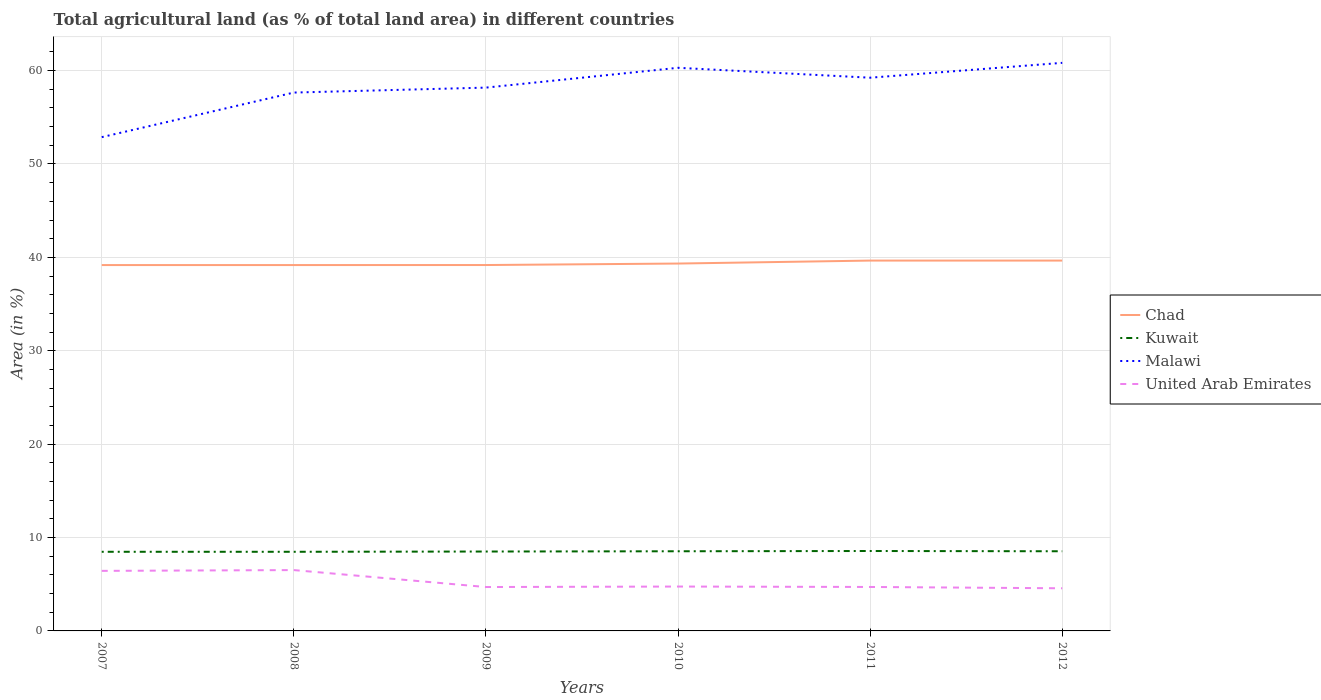Across all years, what is the maximum percentage of agricultural land in Kuwait?
Your answer should be very brief. 8.47. What is the total percentage of agricultural land in Kuwait in the graph?
Provide a short and direct response. -0.03. What is the difference between the highest and the second highest percentage of agricultural land in Kuwait?
Offer a terse response. 0.08. What is the difference between the highest and the lowest percentage of agricultural land in Kuwait?
Your answer should be compact. 3. How many lines are there?
Provide a succinct answer. 4. Does the graph contain grids?
Make the answer very short. Yes. How are the legend labels stacked?
Give a very brief answer. Vertical. What is the title of the graph?
Your answer should be compact. Total agricultural land (as % of total land area) in different countries. Does "Greece" appear as one of the legend labels in the graph?
Provide a short and direct response. No. What is the label or title of the Y-axis?
Provide a short and direct response. Area (in %). What is the Area (in %) in Chad in 2007?
Make the answer very short. 39.18. What is the Area (in %) in Kuwait in 2007?
Your answer should be very brief. 8.47. What is the Area (in %) in Malawi in 2007?
Your answer should be very brief. 52.87. What is the Area (in %) in United Arab Emirates in 2007?
Ensure brevity in your answer.  6.43. What is the Area (in %) in Chad in 2008?
Your response must be concise. 39.18. What is the Area (in %) in Kuwait in 2008?
Make the answer very short. 8.47. What is the Area (in %) in Malawi in 2008?
Ensure brevity in your answer.  57.65. What is the Area (in %) of United Arab Emirates in 2008?
Give a very brief answer. 6.51. What is the Area (in %) of Chad in 2009?
Your answer should be compact. 39.18. What is the Area (in %) of Kuwait in 2009?
Provide a short and direct response. 8.5. What is the Area (in %) in Malawi in 2009?
Keep it short and to the point. 58.18. What is the Area (in %) of United Arab Emirates in 2009?
Offer a terse response. 4.7. What is the Area (in %) in Chad in 2010?
Your answer should be very brief. 39.34. What is the Area (in %) of Kuwait in 2010?
Offer a terse response. 8.53. What is the Area (in %) in Malawi in 2010?
Offer a very short reply. 60.3. What is the Area (in %) of United Arab Emirates in 2010?
Your response must be concise. 4.75. What is the Area (in %) of Chad in 2011?
Offer a very short reply. 39.66. What is the Area (in %) of Kuwait in 2011?
Ensure brevity in your answer.  8.56. What is the Area (in %) in Malawi in 2011?
Provide a short and direct response. 59.24. What is the Area (in %) of United Arab Emirates in 2011?
Keep it short and to the point. 4.71. What is the Area (in %) of Chad in 2012?
Give a very brief answer. 39.66. What is the Area (in %) in Kuwait in 2012?
Make the answer very short. 8.53. What is the Area (in %) of Malawi in 2012?
Keep it short and to the point. 60.83. What is the Area (in %) in United Arab Emirates in 2012?
Provide a succinct answer. 4.57. Across all years, what is the maximum Area (in %) of Chad?
Make the answer very short. 39.66. Across all years, what is the maximum Area (in %) of Kuwait?
Offer a very short reply. 8.56. Across all years, what is the maximum Area (in %) of Malawi?
Provide a short and direct response. 60.83. Across all years, what is the maximum Area (in %) of United Arab Emirates?
Ensure brevity in your answer.  6.51. Across all years, what is the minimum Area (in %) in Chad?
Offer a very short reply. 39.18. Across all years, what is the minimum Area (in %) of Kuwait?
Your answer should be compact. 8.47. Across all years, what is the minimum Area (in %) of Malawi?
Your response must be concise. 52.87. Across all years, what is the minimum Area (in %) in United Arab Emirates?
Provide a short and direct response. 4.57. What is the total Area (in %) of Chad in the graph?
Ensure brevity in your answer.  236.18. What is the total Area (in %) of Kuwait in the graph?
Your answer should be very brief. 51.07. What is the total Area (in %) in Malawi in the graph?
Provide a succinct answer. 349.07. What is the total Area (in %) of United Arab Emirates in the graph?
Provide a short and direct response. 31.67. What is the difference between the Area (in %) of Kuwait in 2007 and that in 2008?
Give a very brief answer. 0. What is the difference between the Area (in %) of Malawi in 2007 and that in 2008?
Keep it short and to the point. -4.77. What is the difference between the Area (in %) in United Arab Emirates in 2007 and that in 2008?
Provide a short and direct response. -0.08. What is the difference between the Area (in %) of Chad in 2007 and that in 2009?
Offer a very short reply. -0. What is the difference between the Area (in %) in Kuwait in 2007 and that in 2009?
Your answer should be very brief. -0.03. What is the difference between the Area (in %) of Malawi in 2007 and that in 2009?
Provide a succinct answer. -5.3. What is the difference between the Area (in %) of United Arab Emirates in 2007 and that in 2009?
Offer a very short reply. 1.73. What is the difference between the Area (in %) of Chad in 2007 and that in 2010?
Offer a terse response. -0.16. What is the difference between the Area (in %) in Kuwait in 2007 and that in 2010?
Your response must be concise. -0.06. What is the difference between the Area (in %) of Malawi in 2007 and that in 2010?
Give a very brief answer. -7.42. What is the difference between the Area (in %) of United Arab Emirates in 2007 and that in 2010?
Make the answer very short. 1.68. What is the difference between the Area (in %) of Chad in 2007 and that in 2011?
Your answer should be very brief. -0.48. What is the difference between the Area (in %) of Kuwait in 2007 and that in 2011?
Provide a short and direct response. -0.08. What is the difference between the Area (in %) of Malawi in 2007 and that in 2011?
Give a very brief answer. -6.36. What is the difference between the Area (in %) of United Arab Emirates in 2007 and that in 2011?
Keep it short and to the point. 1.72. What is the difference between the Area (in %) of Chad in 2007 and that in 2012?
Offer a terse response. -0.48. What is the difference between the Area (in %) of Kuwait in 2007 and that in 2012?
Give a very brief answer. -0.06. What is the difference between the Area (in %) of Malawi in 2007 and that in 2012?
Keep it short and to the point. -7.96. What is the difference between the Area (in %) in United Arab Emirates in 2007 and that in 2012?
Offer a very short reply. 1.86. What is the difference between the Area (in %) in Chad in 2008 and that in 2009?
Offer a terse response. -0. What is the difference between the Area (in %) of Kuwait in 2008 and that in 2009?
Make the answer very short. -0.03. What is the difference between the Area (in %) in Malawi in 2008 and that in 2009?
Offer a terse response. -0.53. What is the difference between the Area (in %) of United Arab Emirates in 2008 and that in 2009?
Offer a terse response. 1.81. What is the difference between the Area (in %) of Chad in 2008 and that in 2010?
Your answer should be very brief. -0.16. What is the difference between the Area (in %) in Kuwait in 2008 and that in 2010?
Offer a terse response. -0.06. What is the difference between the Area (in %) in Malawi in 2008 and that in 2010?
Keep it short and to the point. -2.65. What is the difference between the Area (in %) in United Arab Emirates in 2008 and that in 2010?
Offer a very short reply. 1.76. What is the difference between the Area (in %) in Chad in 2008 and that in 2011?
Provide a short and direct response. -0.48. What is the difference between the Area (in %) of Kuwait in 2008 and that in 2011?
Offer a terse response. -0.08. What is the difference between the Area (in %) in Malawi in 2008 and that in 2011?
Your answer should be compact. -1.59. What is the difference between the Area (in %) of United Arab Emirates in 2008 and that in 2011?
Ensure brevity in your answer.  1.81. What is the difference between the Area (in %) of Chad in 2008 and that in 2012?
Give a very brief answer. -0.48. What is the difference between the Area (in %) in Kuwait in 2008 and that in 2012?
Ensure brevity in your answer.  -0.06. What is the difference between the Area (in %) of Malawi in 2008 and that in 2012?
Keep it short and to the point. -3.18. What is the difference between the Area (in %) in United Arab Emirates in 2008 and that in 2012?
Provide a succinct answer. 1.95. What is the difference between the Area (in %) in Chad in 2009 and that in 2010?
Give a very brief answer. -0.16. What is the difference between the Area (in %) of Kuwait in 2009 and that in 2010?
Provide a succinct answer. -0.03. What is the difference between the Area (in %) of Malawi in 2009 and that in 2010?
Make the answer very short. -2.12. What is the difference between the Area (in %) in United Arab Emirates in 2009 and that in 2010?
Make the answer very short. -0.05. What is the difference between the Area (in %) of Chad in 2009 and that in 2011?
Give a very brief answer. -0.48. What is the difference between the Area (in %) in Kuwait in 2009 and that in 2011?
Keep it short and to the point. -0.06. What is the difference between the Area (in %) in Malawi in 2009 and that in 2011?
Your answer should be compact. -1.06. What is the difference between the Area (in %) of United Arab Emirates in 2009 and that in 2011?
Provide a succinct answer. -0.01. What is the difference between the Area (in %) of Chad in 2009 and that in 2012?
Ensure brevity in your answer.  -0.48. What is the difference between the Area (in %) of Kuwait in 2009 and that in 2012?
Make the answer very short. -0.03. What is the difference between the Area (in %) of Malawi in 2009 and that in 2012?
Your answer should be very brief. -2.65. What is the difference between the Area (in %) in United Arab Emirates in 2009 and that in 2012?
Give a very brief answer. 0.13. What is the difference between the Area (in %) in Chad in 2010 and that in 2011?
Make the answer very short. -0.32. What is the difference between the Area (in %) in Kuwait in 2010 and that in 2011?
Your response must be concise. -0.03. What is the difference between the Area (in %) of Malawi in 2010 and that in 2011?
Give a very brief answer. 1.06. What is the difference between the Area (in %) of United Arab Emirates in 2010 and that in 2011?
Ensure brevity in your answer.  0.05. What is the difference between the Area (in %) of Chad in 2010 and that in 2012?
Your response must be concise. -0.32. What is the difference between the Area (in %) in Malawi in 2010 and that in 2012?
Your answer should be compact. -0.53. What is the difference between the Area (in %) in United Arab Emirates in 2010 and that in 2012?
Offer a very short reply. 0.19. What is the difference between the Area (in %) of Chad in 2011 and that in 2012?
Offer a terse response. 0. What is the difference between the Area (in %) of Kuwait in 2011 and that in 2012?
Make the answer very short. 0.03. What is the difference between the Area (in %) of Malawi in 2011 and that in 2012?
Offer a terse response. -1.59. What is the difference between the Area (in %) of United Arab Emirates in 2011 and that in 2012?
Offer a terse response. 0.14. What is the difference between the Area (in %) in Chad in 2007 and the Area (in %) in Kuwait in 2008?
Provide a short and direct response. 30.7. What is the difference between the Area (in %) of Chad in 2007 and the Area (in %) of Malawi in 2008?
Your answer should be compact. -18.47. What is the difference between the Area (in %) in Chad in 2007 and the Area (in %) in United Arab Emirates in 2008?
Your response must be concise. 32.66. What is the difference between the Area (in %) of Kuwait in 2007 and the Area (in %) of Malawi in 2008?
Ensure brevity in your answer.  -49.17. What is the difference between the Area (in %) of Kuwait in 2007 and the Area (in %) of United Arab Emirates in 2008?
Ensure brevity in your answer.  1.96. What is the difference between the Area (in %) of Malawi in 2007 and the Area (in %) of United Arab Emirates in 2008?
Make the answer very short. 46.36. What is the difference between the Area (in %) of Chad in 2007 and the Area (in %) of Kuwait in 2009?
Give a very brief answer. 30.67. What is the difference between the Area (in %) of Chad in 2007 and the Area (in %) of Malawi in 2009?
Give a very brief answer. -19. What is the difference between the Area (in %) of Chad in 2007 and the Area (in %) of United Arab Emirates in 2009?
Offer a terse response. 34.48. What is the difference between the Area (in %) of Kuwait in 2007 and the Area (in %) of Malawi in 2009?
Your answer should be very brief. -49.7. What is the difference between the Area (in %) in Kuwait in 2007 and the Area (in %) in United Arab Emirates in 2009?
Your answer should be compact. 3.77. What is the difference between the Area (in %) in Malawi in 2007 and the Area (in %) in United Arab Emirates in 2009?
Your response must be concise. 48.17. What is the difference between the Area (in %) in Chad in 2007 and the Area (in %) in Kuwait in 2010?
Provide a short and direct response. 30.65. What is the difference between the Area (in %) of Chad in 2007 and the Area (in %) of Malawi in 2010?
Your answer should be compact. -21.12. What is the difference between the Area (in %) in Chad in 2007 and the Area (in %) in United Arab Emirates in 2010?
Provide a succinct answer. 34.42. What is the difference between the Area (in %) in Kuwait in 2007 and the Area (in %) in Malawi in 2010?
Your answer should be compact. -51.83. What is the difference between the Area (in %) in Kuwait in 2007 and the Area (in %) in United Arab Emirates in 2010?
Your answer should be compact. 3.72. What is the difference between the Area (in %) of Malawi in 2007 and the Area (in %) of United Arab Emirates in 2010?
Your answer should be very brief. 48.12. What is the difference between the Area (in %) in Chad in 2007 and the Area (in %) in Kuwait in 2011?
Provide a succinct answer. 30.62. What is the difference between the Area (in %) in Chad in 2007 and the Area (in %) in Malawi in 2011?
Your answer should be very brief. -20.06. What is the difference between the Area (in %) in Chad in 2007 and the Area (in %) in United Arab Emirates in 2011?
Your answer should be compact. 34.47. What is the difference between the Area (in %) of Kuwait in 2007 and the Area (in %) of Malawi in 2011?
Offer a terse response. -50.76. What is the difference between the Area (in %) of Kuwait in 2007 and the Area (in %) of United Arab Emirates in 2011?
Make the answer very short. 3.77. What is the difference between the Area (in %) in Malawi in 2007 and the Area (in %) in United Arab Emirates in 2011?
Keep it short and to the point. 48.17. What is the difference between the Area (in %) in Chad in 2007 and the Area (in %) in Kuwait in 2012?
Keep it short and to the point. 30.65. What is the difference between the Area (in %) in Chad in 2007 and the Area (in %) in Malawi in 2012?
Keep it short and to the point. -21.65. What is the difference between the Area (in %) of Chad in 2007 and the Area (in %) of United Arab Emirates in 2012?
Keep it short and to the point. 34.61. What is the difference between the Area (in %) of Kuwait in 2007 and the Area (in %) of Malawi in 2012?
Give a very brief answer. -52.36. What is the difference between the Area (in %) in Kuwait in 2007 and the Area (in %) in United Arab Emirates in 2012?
Keep it short and to the point. 3.91. What is the difference between the Area (in %) of Malawi in 2007 and the Area (in %) of United Arab Emirates in 2012?
Your response must be concise. 48.31. What is the difference between the Area (in %) of Chad in 2008 and the Area (in %) of Kuwait in 2009?
Make the answer very short. 30.67. What is the difference between the Area (in %) in Chad in 2008 and the Area (in %) in Malawi in 2009?
Offer a terse response. -19. What is the difference between the Area (in %) of Chad in 2008 and the Area (in %) of United Arab Emirates in 2009?
Give a very brief answer. 34.48. What is the difference between the Area (in %) of Kuwait in 2008 and the Area (in %) of Malawi in 2009?
Your answer should be very brief. -49.7. What is the difference between the Area (in %) of Kuwait in 2008 and the Area (in %) of United Arab Emirates in 2009?
Provide a short and direct response. 3.77. What is the difference between the Area (in %) of Malawi in 2008 and the Area (in %) of United Arab Emirates in 2009?
Your answer should be compact. 52.95. What is the difference between the Area (in %) in Chad in 2008 and the Area (in %) in Kuwait in 2010?
Your response must be concise. 30.65. What is the difference between the Area (in %) of Chad in 2008 and the Area (in %) of Malawi in 2010?
Your answer should be compact. -21.12. What is the difference between the Area (in %) of Chad in 2008 and the Area (in %) of United Arab Emirates in 2010?
Make the answer very short. 34.42. What is the difference between the Area (in %) of Kuwait in 2008 and the Area (in %) of Malawi in 2010?
Provide a short and direct response. -51.83. What is the difference between the Area (in %) of Kuwait in 2008 and the Area (in %) of United Arab Emirates in 2010?
Provide a short and direct response. 3.72. What is the difference between the Area (in %) of Malawi in 2008 and the Area (in %) of United Arab Emirates in 2010?
Your response must be concise. 52.9. What is the difference between the Area (in %) of Chad in 2008 and the Area (in %) of Kuwait in 2011?
Offer a terse response. 30.62. What is the difference between the Area (in %) in Chad in 2008 and the Area (in %) in Malawi in 2011?
Your response must be concise. -20.06. What is the difference between the Area (in %) of Chad in 2008 and the Area (in %) of United Arab Emirates in 2011?
Give a very brief answer. 34.47. What is the difference between the Area (in %) of Kuwait in 2008 and the Area (in %) of Malawi in 2011?
Provide a succinct answer. -50.76. What is the difference between the Area (in %) of Kuwait in 2008 and the Area (in %) of United Arab Emirates in 2011?
Keep it short and to the point. 3.77. What is the difference between the Area (in %) in Malawi in 2008 and the Area (in %) in United Arab Emirates in 2011?
Your answer should be very brief. 52.94. What is the difference between the Area (in %) of Chad in 2008 and the Area (in %) of Kuwait in 2012?
Your response must be concise. 30.65. What is the difference between the Area (in %) of Chad in 2008 and the Area (in %) of Malawi in 2012?
Offer a terse response. -21.65. What is the difference between the Area (in %) of Chad in 2008 and the Area (in %) of United Arab Emirates in 2012?
Provide a short and direct response. 34.61. What is the difference between the Area (in %) of Kuwait in 2008 and the Area (in %) of Malawi in 2012?
Offer a very short reply. -52.36. What is the difference between the Area (in %) in Kuwait in 2008 and the Area (in %) in United Arab Emirates in 2012?
Ensure brevity in your answer.  3.91. What is the difference between the Area (in %) in Malawi in 2008 and the Area (in %) in United Arab Emirates in 2012?
Offer a very short reply. 53.08. What is the difference between the Area (in %) in Chad in 2009 and the Area (in %) in Kuwait in 2010?
Provide a short and direct response. 30.65. What is the difference between the Area (in %) of Chad in 2009 and the Area (in %) of Malawi in 2010?
Ensure brevity in your answer.  -21.12. What is the difference between the Area (in %) of Chad in 2009 and the Area (in %) of United Arab Emirates in 2010?
Give a very brief answer. 34.43. What is the difference between the Area (in %) of Kuwait in 2009 and the Area (in %) of Malawi in 2010?
Your answer should be very brief. -51.8. What is the difference between the Area (in %) in Kuwait in 2009 and the Area (in %) in United Arab Emirates in 2010?
Provide a short and direct response. 3.75. What is the difference between the Area (in %) in Malawi in 2009 and the Area (in %) in United Arab Emirates in 2010?
Offer a very short reply. 53.43. What is the difference between the Area (in %) in Chad in 2009 and the Area (in %) in Kuwait in 2011?
Your answer should be compact. 30.62. What is the difference between the Area (in %) of Chad in 2009 and the Area (in %) of Malawi in 2011?
Your answer should be very brief. -20.06. What is the difference between the Area (in %) of Chad in 2009 and the Area (in %) of United Arab Emirates in 2011?
Ensure brevity in your answer.  34.47. What is the difference between the Area (in %) in Kuwait in 2009 and the Area (in %) in Malawi in 2011?
Ensure brevity in your answer.  -50.74. What is the difference between the Area (in %) in Kuwait in 2009 and the Area (in %) in United Arab Emirates in 2011?
Ensure brevity in your answer.  3.79. What is the difference between the Area (in %) in Malawi in 2009 and the Area (in %) in United Arab Emirates in 2011?
Your answer should be compact. 53.47. What is the difference between the Area (in %) of Chad in 2009 and the Area (in %) of Kuwait in 2012?
Ensure brevity in your answer.  30.65. What is the difference between the Area (in %) of Chad in 2009 and the Area (in %) of Malawi in 2012?
Your answer should be very brief. -21.65. What is the difference between the Area (in %) in Chad in 2009 and the Area (in %) in United Arab Emirates in 2012?
Offer a terse response. 34.61. What is the difference between the Area (in %) of Kuwait in 2009 and the Area (in %) of Malawi in 2012?
Offer a very short reply. -52.33. What is the difference between the Area (in %) in Kuwait in 2009 and the Area (in %) in United Arab Emirates in 2012?
Your response must be concise. 3.94. What is the difference between the Area (in %) of Malawi in 2009 and the Area (in %) of United Arab Emirates in 2012?
Offer a terse response. 53.61. What is the difference between the Area (in %) in Chad in 2010 and the Area (in %) in Kuwait in 2011?
Provide a short and direct response. 30.78. What is the difference between the Area (in %) in Chad in 2010 and the Area (in %) in Malawi in 2011?
Give a very brief answer. -19.9. What is the difference between the Area (in %) in Chad in 2010 and the Area (in %) in United Arab Emirates in 2011?
Ensure brevity in your answer.  34.63. What is the difference between the Area (in %) in Kuwait in 2010 and the Area (in %) in Malawi in 2011?
Your answer should be compact. -50.71. What is the difference between the Area (in %) of Kuwait in 2010 and the Area (in %) of United Arab Emirates in 2011?
Provide a succinct answer. 3.82. What is the difference between the Area (in %) in Malawi in 2010 and the Area (in %) in United Arab Emirates in 2011?
Make the answer very short. 55.59. What is the difference between the Area (in %) in Chad in 2010 and the Area (in %) in Kuwait in 2012?
Make the answer very short. 30.81. What is the difference between the Area (in %) in Chad in 2010 and the Area (in %) in Malawi in 2012?
Give a very brief answer. -21.49. What is the difference between the Area (in %) of Chad in 2010 and the Area (in %) of United Arab Emirates in 2012?
Provide a succinct answer. 34.77. What is the difference between the Area (in %) in Kuwait in 2010 and the Area (in %) in Malawi in 2012?
Provide a succinct answer. -52.3. What is the difference between the Area (in %) of Kuwait in 2010 and the Area (in %) of United Arab Emirates in 2012?
Keep it short and to the point. 3.96. What is the difference between the Area (in %) of Malawi in 2010 and the Area (in %) of United Arab Emirates in 2012?
Your answer should be very brief. 55.73. What is the difference between the Area (in %) of Chad in 2011 and the Area (in %) of Kuwait in 2012?
Offer a very short reply. 31.13. What is the difference between the Area (in %) of Chad in 2011 and the Area (in %) of Malawi in 2012?
Your response must be concise. -21.17. What is the difference between the Area (in %) in Chad in 2011 and the Area (in %) in United Arab Emirates in 2012?
Provide a short and direct response. 35.09. What is the difference between the Area (in %) of Kuwait in 2011 and the Area (in %) of Malawi in 2012?
Provide a short and direct response. -52.27. What is the difference between the Area (in %) in Kuwait in 2011 and the Area (in %) in United Arab Emirates in 2012?
Keep it short and to the point. 3.99. What is the difference between the Area (in %) of Malawi in 2011 and the Area (in %) of United Arab Emirates in 2012?
Ensure brevity in your answer.  54.67. What is the average Area (in %) in Chad per year?
Offer a terse response. 39.36. What is the average Area (in %) of Kuwait per year?
Offer a terse response. 8.51. What is the average Area (in %) in Malawi per year?
Your answer should be very brief. 58.18. What is the average Area (in %) of United Arab Emirates per year?
Provide a succinct answer. 5.28. In the year 2007, what is the difference between the Area (in %) of Chad and Area (in %) of Kuwait?
Provide a succinct answer. 30.7. In the year 2007, what is the difference between the Area (in %) in Chad and Area (in %) in Malawi?
Make the answer very short. -13.7. In the year 2007, what is the difference between the Area (in %) in Chad and Area (in %) in United Arab Emirates?
Your response must be concise. 32.75. In the year 2007, what is the difference between the Area (in %) in Kuwait and Area (in %) in Malawi?
Your response must be concise. -44.4. In the year 2007, what is the difference between the Area (in %) in Kuwait and Area (in %) in United Arab Emirates?
Offer a very short reply. 2.04. In the year 2007, what is the difference between the Area (in %) of Malawi and Area (in %) of United Arab Emirates?
Make the answer very short. 46.44. In the year 2008, what is the difference between the Area (in %) in Chad and Area (in %) in Kuwait?
Offer a terse response. 30.7. In the year 2008, what is the difference between the Area (in %) of Chad and Area (in %) of Malawi?
Offer a very short reply. -18.47. In the year 2008, what is the difference between the Area (in %) in Chad and Area (in %) in United Arab Emirates?
Provide a short and direct response. 32.66. In the year 2008, what is the difference between the Area (in %) in Kuwait and Area (in %) in Malawi?
Give a very brief answer. -49.17. In the year 2008, what is the difference between the Area (in %) of Kuwait and Area (in %) of United Arab Emirates?
Your answer should be compact. 1.96. In the year 2008, what is the difference between the Area (in %) of Malawi and Area (in %) of United Arab Emirates?
Your answer should be compact. 51.13. In the year 2009, what is the difference between the Area (in %) in Chad and Area (in %) in Kuwait?
Your response must be concise. 30.68. In the year 2009, what is the difference between the Area (in %) in Chad and Area (in %) in Malawi?
Keep it short and to the point. -19. In the year 2009, what is the difference between the Area (in %) of Chad and Area (in %) of United Arab Emirates?
Make the answer very short. 34.48. In the year 2009, what is the difference between the Area (in %) of Kuwait and Area (in %) of Malawi?
Give a very brief answer. -49.68. In the year 2009, what is the difference between the Area (in %) of Kuwait and Area (in %) of United Arab Emirates?
Keep it short and to the point. 3.8. In the year 2009, what is the difference between the Area (in %) of Malawi and Area (in %) of United Arab Emirates?
Provide a short and direct response. 53.48. In the year 2010, what is the difference between the Area (in %) of Chad and Area (in %) of Kuwait?
Provide a short and direct response. 30.81. In the year 2010, what is the difference between the Area (in %) of Chad and Area (in %) of Malawi?
Give a very brief answer. -20.96. In the year 2010, what is the difference between the Area (in %) in Chad and Area (in %) in United Arab Emirates?
Make the answer very short. 34.59. In the year 2010, what is the difference between the Area (in %) of Kuwait and Area (in %) of Malawi?
Your response must be concise. -51.77. In the year 2010, what is the difference between the Area (in %) of Kuwait and Area (in %) of United Arab Emirates?
Your answer should be very brief. 3.78. In the year 2010, what is the difference between the Area (in %) in Malawi and Area (in %) in United Arab Emirates?
Your answer should be compact. 55.55. In the year 2011, what is the difference between the Area (in %) of Chad and Area (in %) of Kuwait?
Your response must be concise. 31.1. In the year 2011, what is the difference between the Area (in %) in Chad and Area (in %) in Malawi?
Keep it short and to the point. -19.58. In the year 2011, what is the difference between the Area (in %) in Chad and Area (in %) in United Arab Emirates?
Offer a very short reply. 34.95. In the year 2011, what is the difference between the Area (in %) of Kuwait and Area (in %) of Malawi?
Make the answer very short. -50.68. In the year 2011, what is the difference between the Area (in %) of Kuwait and Area (in %) of United Arab Emirates?
Your answer should be compact. 3.85. In the year 2011, what is the difference between the Area (in %) in Malawi and Area (in %) in United Arab Emirates?
Keep it short and to the point. 54.53. In the year 2012, what is the difference between the Area (in %) of Chad and Area (in %) of Kuwait?
Your answer should be very brief. 31.13. In the year 2012, what is the difference between the Area (in %) in Chad and Area (in %) in Malawi?
Your answer should be very brief. -21.17. In the year 2012, what is the difference between the Area (in %) in Chad and Area (in %) in United Arab Emirates?
Ensure brevity in your answer.  35.09. In the year 2012, what is the difference between the Area (in %) in Kuwait and Area (in %) in Malawi?
Offer a very short reply. -52.3. In the year 2012, what is the difference between the Area (in %) in Kuwait and Area (in %) in United Arab Emirates?
Provide a succinct answer. 3.96. In the year 2012, what is the difference between the Area (in %) in Malawi and Area (in %) in United Arab Emirates?
Your answer should be compact. 56.26. What is the ratio of the Area (in %) of Malawi in 2007 to that in 2008?
Your answer should be compact. 0.92. What is the ratio of the Area (in %) of United Arab Emirates in 2007 to that in 2008?
Keep it short and to the point. 0.99. What is the ratio of the Area (in %) in Malawi in 2007 to that in 2009?
Make the answer very short. 0.91. What is the ratio of the Area (in %) in United Arab Emirates in 2007 to that in 2009?
Offer a terse response. 1.37. What is the ratio of the Area (in %) of Malawi in 2007 to that in 2010?
Keep it short and to the point. 0.88. What is the ratio of the Area (in %) of United Arab Emirates in 2007 to that in 2010?
Offer a terse response. 1.35. What is the ratio of the Area (in %) in Chad in 2007 to that in 2011?
Provide a short and direct response. 0.99. What is the ratio of the Area (in %) in Kuwait in 2007 to that in 2011?
Keep it short and to the point. 0.99. What is the ratio of the Area (in %) of Malawi in 2007 to that in 2011?
Ensure brevity in your answer.  0.89. What is the ratio of the Area (in %) in United Arab Emirates in 2007 to that in 2011?
Keep it short and to the point. 1.37. What is the ratio of the Area (in %) of Chad in 2007 to that in 2012?
Your answer should be very brief. 0.99. What is the ratio of the Area (in %) of Malawi in 2007 to that in 2012?
Make the answer very short. 0.87. What is the ratio of the Area (in %) in United Arab Emirates in 2007 to that in 2012?
Offer a terse response. 1.41. What is the ratio of the Area (in %) in Kuwait in 2008 to that in 2009?
Provide a succinct answer. 1. What is the ratio of the Area (in %) of Malawi in 2008 to that in 2009?
Provide a short and direct response. 0.99. What is the ratio of the Area (in %) in United Arab Emirates in 2008 to that in 2009?
Give a very brief answer. 1.39. What is the ratio of the Area (in %) of Chad in 2008 to that in 2010?
Make the answer very short. 1. What is the ratio of the Area (in %) of Malawi in 2008 to that in 2010?
Your answer should be very brief. 0.96. What is the ratio of the Area (in %) in United Arab Emirates in 2008 to that in 2010?
Provide a succinct answer. 1.37. What is the ratio of the Area (in %) of Chad in 2008 to that in 2011?
Your answer should be compact. 0.99. What is the ratio of the Area (in %) of Kuwait in 2008 to that in 2011?
Your answer should be very brief. 0.99. What is the ratio of the Area (in %) of Malawi in 2008 to that in 2011?
Provide a succinct answer. 0.97. What is the ratio of the Area (in %) of United Arab Emirates in 2008 to that in 2011?
Your answer should be very brief. 1.38. What is the ratio of the Area (in %) of Chad in 2008 to that in 2012?
Your response must be concise. 0.99. What is the ratio of the Area (in %) of Kuwait in 2008 to that in 2012?
Provide a short and direct response. 0.99. What is the ratio of the Area (in %) in Malawi in 2008 to that in 2012?
Ensure brevity in your answer.  0.95. What is the ratio of the Area (in %) in United Arab Emirates in 2008 to that in 2012?
Give a very brief answer. 1.43. What is the ratio of the Area (in %) in Malawi in 2009 to that in 2010?
Your response must be concise. 0.96. What is the ratio of the Area (in %) of United Arab Emirates in 2009 to that in 2010?
Keep it short and to the point. 0.99. What is the ratio of the Area (in %) in Malawi in 2009 to that in 2011?
Offer a terse response. 0.98. What is the ratio of the Area (in %) in Kuwait in 2009 to that in 2012?
Provide a short and direct response. 1. What is the ratio of the Area (in %) in Malawi in 2009 to that in 2012?
Your response must be concise. 0.96. What is the ratio of the Area (in %) of United Arab Emirates in 2009 to that in 2012?
Your answer should be very brief. 1.03. What is the ratio of the Area (in %) of Kuwait in 2010 to that in 2011?
Give a very brief answer. 1. What is the ratio of the Area (in %) in Malawi in 2010 to that in 2011?
Your response must be concise. 1.02. What is the ratio of the Area (in %) of United Arab Emirates in 2010 to that in 2011?
Keep it short and to the point. 1.01. What is the ratio of the Area (in %) of Chad in 2010 to that in 2012?
Offer a very short reply. 0.99. What is the ratio of the Area (in %) of Kuwait in 2010 to that in 2012?
Your response must be concise. 1. What is the ratio of the Area (in %) of United Arab Emirates in 2010 to that in 2012?
Your answer should be compact. 1.04. What is the ratio of the Area (in %) in Chad in 2011 to that in 2012?
Keep it short and to the point. 1. What is the ratio of the Area (in %) in Malawi in 2011 to that in 2012?
Offer a terse response. 0.97. What is the ratio of the Area (in %) in United Arab Emirates in 2011 to that in 2012?
Your answer should be compact. 1.03. What is the difference between the highest and the second highest Area (in %) in Chad?
Your answer should be compact. 0. What is the difference between the highest and the second highest Area (in %) in Kuwait?
Provide a short and direct response. 0.03. What is the difference between the highest and the second highest Area (in %) in Malawi?
Offer a terse response. 0.53. What is the difference between the highest and the second highest Area (in %) in United Arab Emirates?
Offer a very short reply. 0.08. What is the difference between the highest and the lowest Area (in %) of Chad?
Provide a short and direct response. 0.48. What is the difference between the highest and the lowest Area (in %) of Kuwait?
Make the answer very short. 0.08. What is the difference between the highest and the lowest Area (in %) of Malawi?
Offer a very short reply. 7.96. What is the difference between the highest and the lowest Area (in %) of United Arab Emirates?
Your answer should be compact. 1.95. 